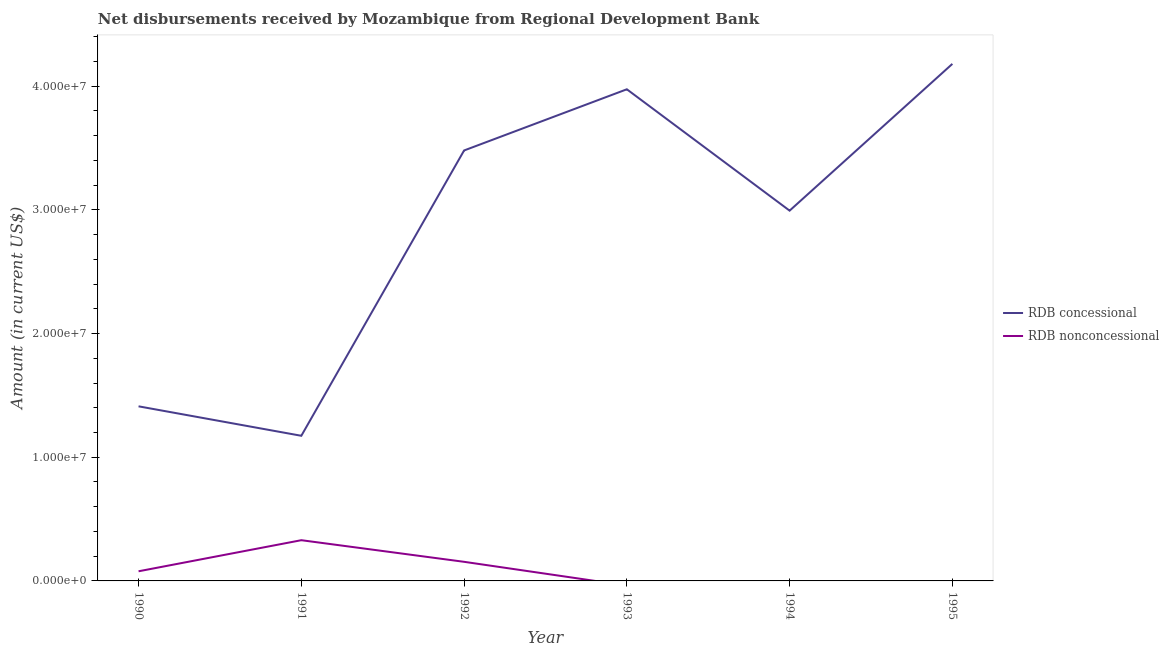Does the line corresponding to net concessional disbursements from rdb intersect with the line corresponding to net non concessional disbursements from rdb?
Your answer should be very brief. No. Is the number of lines equal to the number of legend labels?
Ensure brevity in your answer.  No. What is the net concessional disbursements from rdb in 1990?
Give a very brief answer. 1.41e+07. Across all years, what is the maximum net non concessional disbursements from rdb?
Offer a terse response. 3.29e+06. Across all years, what is the minimum net concessional disbursements from rdb?
Make the answer very short. 1.17e+07. In which year was the net non concessional disbursements from rdb maximum?
Your response must be concise. 1991. What is the total net non concessional disbursements from rdb in the graph?
Offer a terse response. 5.62e+06. What is the difference between the net concessional disbursements from rdb in 1990 and that in 1992?
Keep it short and to the point. -2.07e+07. What is the difference between the net non concessional disbursements from rdb in 1990 and the net concessional disbursements from rdb in 1993?
Your response must be concise. -3.90e+07. What is the average net non concessional disbursements from rdb per year?
Make the answer very short. 9.36e+05. In the year 1991, what is the difference between the net non concessional disbursements from rdb and net concessional disbursements from rdb?
Your answer should be very brief. -8.44e+06. In how many years, is the net non concessional disbursements from rdb greater than 36000000 US$?
Offer a terse response. 0. What is the ratio of the net concessional disbursements from rdb in 1992 to that in 1993?
Offer a very short reply. 0.88. Is the difference between the net non concessional disbursements from rdb in 1990 and 1992 greater than the difference between the net concessional disbursements from rdb in 1990 and 1992?
Your answer should be very brief. Yes. What is the difference between the highest and the second highest net non concessional disbursements from rdb?
Offer a terse response. 1.75e+06. What is the difference between the highest and the lowest net concessional disbursements from rdb?
Your response must be concise. 3.01e+07. How many lines are there?
Offer a very short reply. 2. How many years are there in the graph?
Make the answer very short. 6. Where does the legend appear in the graph?
Offer a very short reply. Center right. How are the legend labels stacked?
Make the answer very short. Vertical. What is the title of the graph?
Your answer should be compact. Net disbursements received by Mozambique from Regional Development Bank. What is the label or title of the X-axis?
Ensure brevity in your answer.  Year. What is the Amount (in current US$) of RDB concessional in 1990?
Provide a succinct answer. 1.41e+07. What is the Amount (in current US$) of RDB nonconcessional in 1990?
Offer a terse response. 7.79e+05. What is the Amount (in current US$) in RDB concessional in 1991?
Offer a very short reply. 1.17e+07. What is the Amount (in current US$) in RDB nonconcessional in 1991?
Offer a terse response. 3.29e+06. What is the Amount (in current US$) in RDB concessional in 1992?
Provide a succinct answer. 3.48e+07. What is the Amount (in current US$) in RDB nonconcessional in 1992?
Make the answer very short. 1.54e+06. What is the Amount (in current US$) of RDB concessional in 1993?
Your answer should be very brief. 3.98e+07. What is the Amount (in current US$) in RDB nonconcessional in 1993?
Ensure brevity in your answer.  0. What is the Amount (in current US$) of RDB concessional in 1994?
Offer a terse response. 2.99e+07. What is the Amount (in current US$) of RDB nonconcessional in 1994?
Make the answer very short. 0. What is the Amount (in current US$) in RDB concessional in 1995?
Give a very brief answer. 4.18e+07. Across all years, what is the maximum Amount (in current US$) in RDB concessional?
Your response must be concise. 4.18e+07. Across all years, what is the maximum Amount (in current US$) of RDB nonconcessional?
Your answer should be compact. 3.29e+06. Across all years, what is the minimum Amount (in current US$) of RDB concessional?
Make the answer very short. 1.17e+07. What is the total Amount (in current US$) in RDB concessional in the graph?
Give a very brief answer. 1.72e+08. What is the total Amount (in current US$) of RDB nonconcessional in the graph?
Your response must be concise. 5.62e+06. What is the difference between the Amount (in current US$) of RDB concessional in 1990 and that in 1991?
Ensure brevity in your answer.  2.38e+06. What is the difference between the Amount (in current US$) of RDB nonconcessional in 1990 and that in 1991?
Provide a succinct answer. -2.51e+06. What is the difference between the Amount (in current US$) in RDB concessional in 1990 and that in 1992?
Provide a short and direct response. -2.07e+07. What is the difference between the Amount (in current US$) of RDB nonconcessional in 1990 and that in 1992?
Your answer should be very brief. -7.66e+05. What is the difference between the Amount (in current US$) in RDB concessional in 1990 and that in 1993?
Ensure brevity in your answer.  -2.56e+07. What is the difference between the Amount (in current US$) in RDB concessional in 1990 and that in 1994?
Offer a very short reply. -1.58e+07. What is the difference between the Amount (in current US$) in RDB concessional in 1990 and that in 1995?
Your answer should be compact. -2.77e+07. What is the difference between the Amount (in current US$) of RDB concessional in 1991 and that in 1992?
Provide a succinct answer. -2.31e+07. What is the difference between the Amount (in current US$) in RDB nonconcessional in 1991 and that in 1992?
Provide a succinct answer. 1.75e+06. What is the difference between the Amount (in current US$) in RDB concessional in 1991 and that in 1993?
Ensure brevity in your answer.  -2.80e+07. What is the difference between the Amount (in current US$) of RDB concessional in 1991 and that in 1994?
Offer a terse response. -1.82e+07. What is the difference between the Amount (in current US$) of RDB concessional in 1991 and that in 1995?
Offer a very short reply. -3.01e+07. What is the difference between the Amount (in current US$) in RDB concessional in 1992 and that in 1993?
Your response must be concise. -4.95e+06. What is the difference between the Amount (in current US$) in RDB concessional in 1992 and that in 1994?
Offer a terse response. 4.87e+06. What is the difference between the Amount (in current US$) of RDB concessional in 1992 and that in 1995?
Provide a short and direct response. -7.00e+06. What is the difference between the Amount (in current US$) of RDB concessional in 1993 and that in 1994?
Provide a short and direct response. 9.81e+06. What is the difference between the Amount (in current US$) in RDB concessional in 1993 and that in 1995?
Offer a terse response. -2.05e+06. What is the difference between the Amount (in current US$) in RDB concessional in 1994 and that in 1995?
Your answer should be compact. -1.19e+07. What is the difference between the Amount (in current US$) of RDB concessional in 1990 and the Amount (in current US$) of RDB nonconcessional in 1991?
Your answer should be compact. 1.08e+07. What is the difference between the Amount (in current US$) in RDB concessional in 1990 and the Amount (in current US$) in RDB nonconcessional in 1992?
Offer a terse response. 1.26e+07. What is the difference between the Amount (in current US$) of RDB concessional in 1991 and the Amount (in current US$) of RDB nonconcessional in 1992?
Offer a very short reply. 1.02e+07. What is the average Amount (in current US$) in RDB concessional per year?
Provide a succinct answer. 2.87e+07. What is the average Amount (in current US$) in RDB nonconcessional per year?
Provide a succinct answer. 9.36e+05. In the year 1990, what is the difference between the Amount (in current US$) in RDB concessional and Amount (in current US$) in RDB nonconcessional?
Offer a very short reply. 1.33e+07. In the year 1991, what is the difference between the Amount (in current US$) of RDB concessional and Amount (in current US$) of RDB nonconcessional?
Provide a succinct answer. 8.44e+06. In the year 1992, what is the difference between the Amount (in current US$) of RDB concessional and Amount (in current US$) of RDB nonconcessional?
Offer a very short reply. 3.33e+07. What is the ratio of the Amount (in current US$) of RDB concessional in 1990 to that in 1991?
Your answer should be compact. 1.2. What is the ratio of the Amount (in current US$) of RDB nonconcessional in 1990 to that in 1991?
Keep it short and to the point. 0.24. What is the ratio of the Amount (in current US$) of RDB concessional in 1990 to that in 1992?
Ensure brevity in your answer.  0.41. What is the ratio of the Amount (in current US$) in RDB nonconcessional in 1990 to that in 1992?
Offer a very short reply. 0.5. What is the ratio of the Amount (in current US$) in RDB concessional in 1990 to that in 1993?
Offer a very short reply. 0.36. What is the ratio of the Amount (in current US$) of RDB concessional in 1990 to that in 1994?
Keep it short and to the point. 0.47. What is the ratio of the Amount (in current US$) of RDB concessional in 1990 to that in 1995?
Provide a short and direct response. 0.34. What is the ratio of the Amount (in current US$) of RDB concessional in 1991 to that in 1992?
Ensure brevity in your answer.  0.34. What is the ratio of the Amount (in current US$) of RDB nonconcessional in 1991 to that in 1992?
Offer a terse response. 2.13. What is the ratio of the Amount (in current US$) of RDB concessional in 1991 to that in 1993?
Provide a succinct answer. 0.3. What is the ratio of the Amount (in current US$) of RDB concessional in 1991 to that in 1994?
Provide a short and direct response. 0.39. What is the ratio of the Amount (in current US$) of RDB concessional in 1991 to that in 1995?
Your response must be concise. 0.28. What is the ratio of the Amount (in current US$) of RDB concessional in 1992 to that in 1993?
Keep it short and to the point. 0.88. What is the ratio of the Amount (in current US$) of RDB concessional in 1992 to that in 1994?
Keep it short and to the point. 1.16. What is the ratio of the Amount (in current US$) of RDB concessional in 1992 to that in 1995?
Offer a terse response. 0.83. What is the ratio of the Amount (in current US$) of RDB concessional in 1993 to that in 1994?
Your answer should be very brief. 1.33. What is the ratio of the Amount (in current US$) in RDB concessional in 1993 to that in 1995?
Your answer should be very brief. 0.95. What is the ratio of the Amount (in current US$) in RDB concessional in 1994 to that in 1995?
Offer a terse response. 0.72. What is the difference between the highest and the second highest Amount (in current US$) of RDB concessional?
Provide a short and direct response. 2.05e+06. What is the difference between the highest and the second highest Amount (in current US$) in RDB nonconcessional?
Give a very brief answer. 1.75e+06. What is the difference between the highest and the lowest Amount (in current US$) in RDB concessional?
Make the answer very short. 3.01e+07. What is the difference between the highest and the lowest Amount (in current US$) of RDB nonconcessional?
Your answer should be compact. 3.29e+06. 